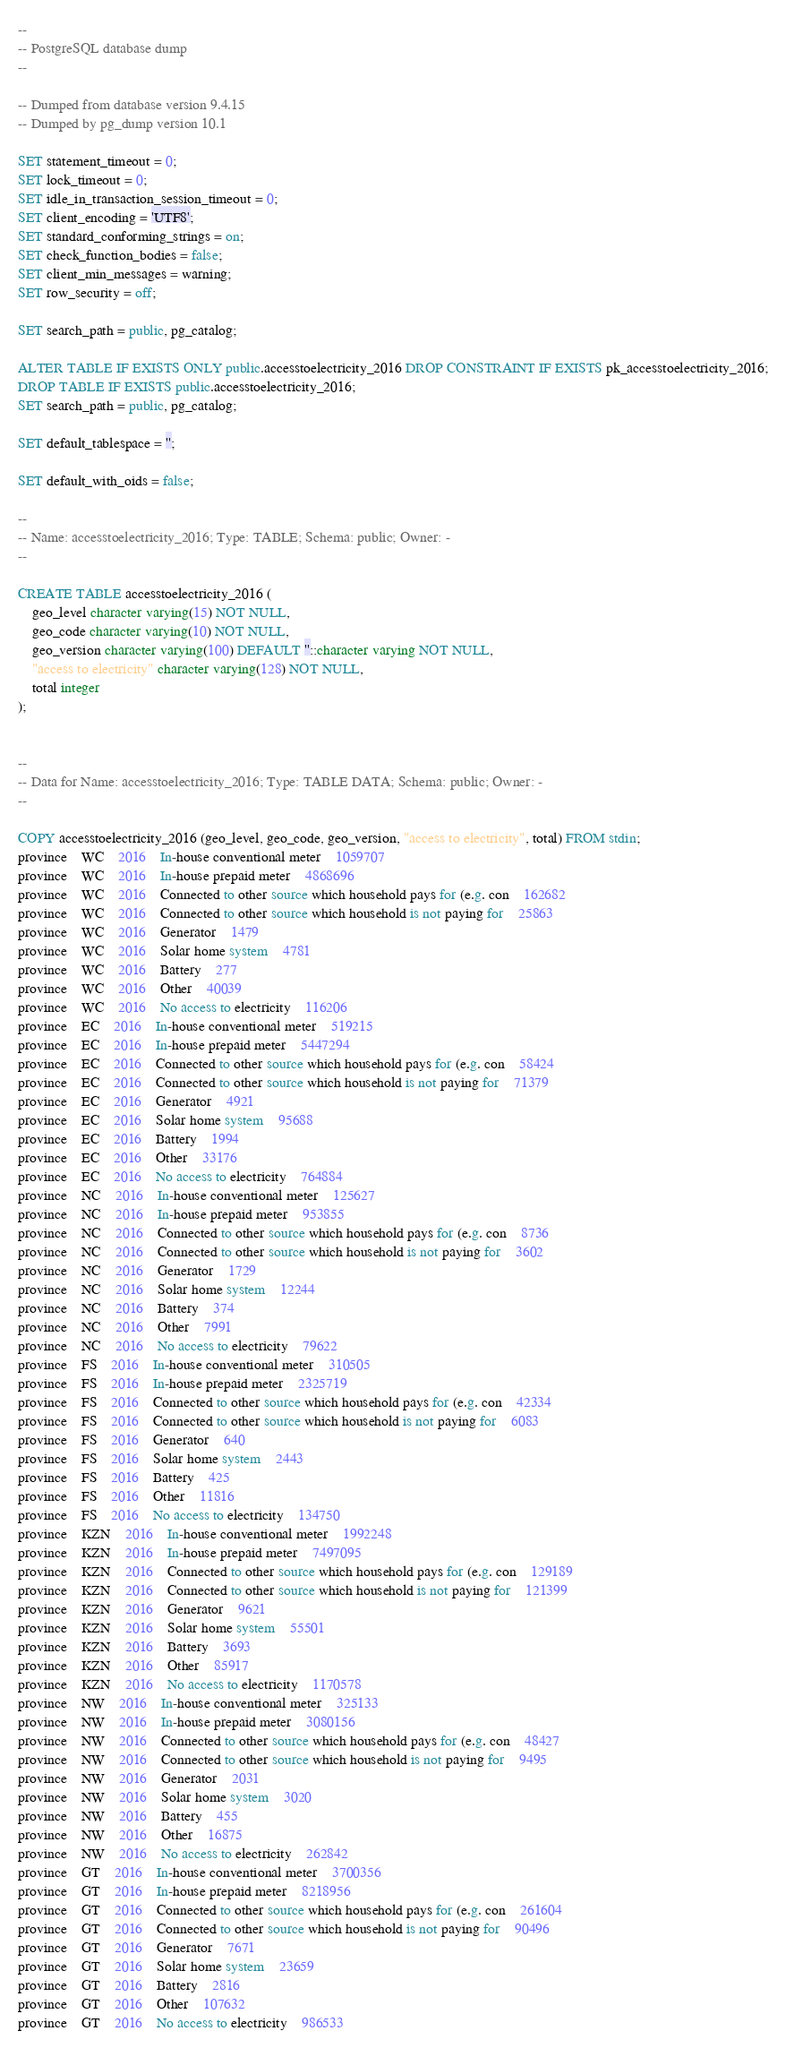Convert code to text. <code><loc_0><loc_0><loc_500><loc_500><_SQL_>--
-- PostgreSQL database dump
--

-- Dumped from database version 9.4.15
-- Dumped by pg_dump version 10.1

SET statement_timeout = 0;
SET lock_timeout = 0;
SET idle_in_transaction_session_timeout = 0;
SET client_encoding = 'UTF8';
SET standard_conforming_strings = on;
SET check_function_bodies = false;
SET client_min_messages = warning;
SET row_security = off;

SET search_path = public, pg_catalog;

ALTER TABLE IF EXISTS ONLY public.accesstoelectricity_2016 DROP CONSTRAINT IF EXISTS pk_accesstoelectricity_2016;
DROP TABLE IF EXISTS public.accesstoelectricity_2016;
SET search_path = public, pg_catalog;

SET default_tablespace = '';

SET default_with_oids = false;

--
-- Name: accesstoelectricity_2016; Type: TABLE; Schema: public; Owner: -
--

CREATE TABLE accesstoelectricity_2016 (
    geo_level character varying(15) NOT NULL,
    geo_code character varying(10) NOT NULL,
    geo_version character varying(100) DEFAULT ''::character varying NOT NULL,
    "access to electricity" character varying(128) NOT NULL,
    total integer
);


--
-- Data for Name: accesstoelectricity_2016; Type: TABLE DATA; Schema: public; Owner: -
--

COPY accesstoelectricity_2016 (geo_level, geo_code, geo_version, "access to electricity", total) FROM stdin;
province	WC	2016	In-house conventional meter	1059707
province	WC	2016	In-house prepaid meter	4868696
province	WC	2016	Connected to other source which household pays for (e.g. con	162682
province	WC	2016	Connected to other source which household is not paying for	25863
province	WC	2016	Generator	1479
province	WC	2016	Solar home system	4781
province	WC	2016	Battery	277
province	WC	2016	Other	40039
province	WC	2016	No access to electricity	116206
province	EC	2016	In-house conventional meter	519215
province	EC	2016	In-house prepaid meter	5447294
province	EC	2016	Connected to other source which household pays for (e.g. con	58424
province	EC	2016	Connected to other source which household is not paying for	71379
province	EC	2016	Generator	4921
province	EC	2016	Solar home system	95688
province	EC	2016	Battery	1994
province	EC	2016	Other	33176
province	EC	2016	No access to electricity	764884
province	NC	2016	In-house conventional meter	125627
province	NC	2016	In-house prepaid meter	953855
province	NC	2016	Connected to other source which household pays for (e.g. con	8736
province	NC	2016	Connected to other source which household is not paying for	3602
province	NC	2016	Generator	1729
province	NC	2016	Solar home system	12244
province	NC	2016	Battery	374
province	NC	2016	Other	7991
province	NC	2016	No access to electricity	79622
province	FS	2016	In-house conventional meter	310505
province	FS	2016	In-house prepaid meter	2325719
province	FS	2016	Connected to other source which household pays for (e.g. con	42334
province	FS	2016	Connected to other source which household is not paying for	6083
province	FS	2016	Generator	640
province	FS	2016	Solar home system	2443
province	FS	2016	Battery	425
province	FS	2016	Other	11816
province	FS	2016	No access to electricity	134750
province	KZN	2016	In-house conventional meter	1992248
province	KZN	2016	In-house prepaid meter	7497095
province	KZN	2016	Connected to other source which household pays for (e.g. con	129189
province	KZN	2016	Connected to other source which household is not paying for	121399
province	KZN	2016	Generator	9621
province	KZN	2016	Solar home system	55501
province	KZN	2016	Battery	3693
province	KZN	2016	Other	85917
province	KZN	2016	No access to electricity	1170578
province	NW	2016	In-house conventional meter	325133
province	NW	2016	In-house prepaid meter	3080156
province	NW	2016	Connected to other source which household pays for (e.g. con	48427
province	NW	2016	Connected to other source which household is not paying for	9495
province	NW	2016	Generator	2031
province	NW	2016	Solar home system	3020
province	NW	2016	Battery	455
province	NW	2016	Other	16875
province	NW	2016	No access to electricity	262842
province	GT	2016	In-house conventional meter	3700356
province	GT	2016	In-house prepaid meter	8218956
province	GT	2016	Connected to other source which household pays for (e.g. con	261604
province	GT	2016	Connected to other source which household is not paying for	90496
province	GT	2016	Generator	7671
province	GT	2016	Solar home system	23659
province	GT	2016	Battery	2816
province	GT	2016	Other	107632
province	GT	2016	No access to electricity	986533</code> 